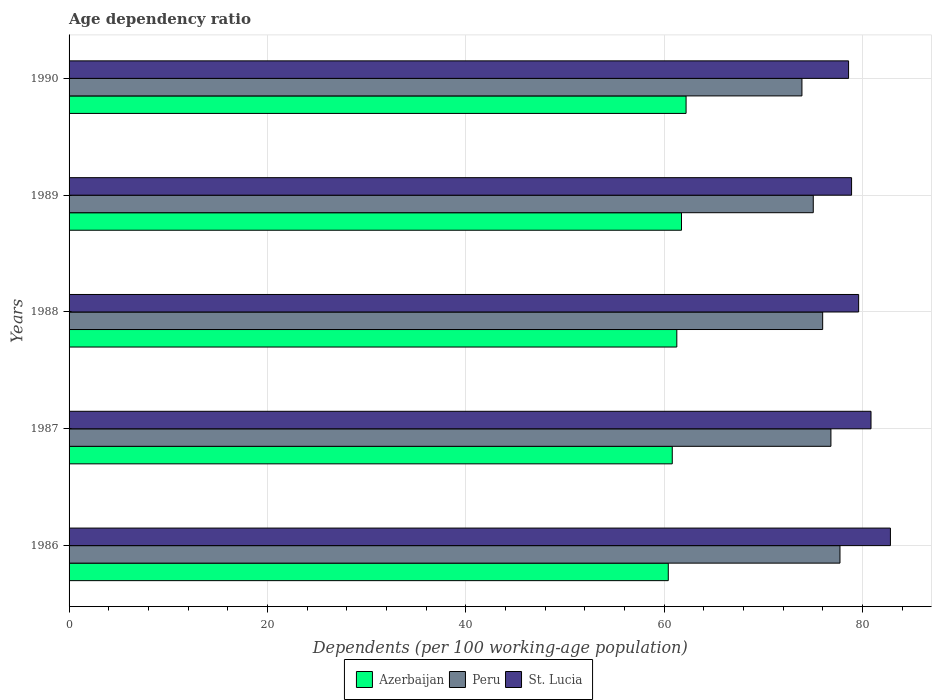How many groups of bars are there?
Offer a very short reply. 5. How many bars are there on the 1st tick from the top?
Offer a very short reply. 3. What is the label of the 3rd group of bars from the top?
Provide a succinct answer. 1988. What is the age dependency ratio in in Azerbaijan in 1989?
Offer a terse response. 61.76. Across all years, what is the maximum age dependency ratio in in Azerbaijan?
Your response must be concise. 62.22. Across all years, what is the minimum age dependency ratio in in St. Lucia?
Provide a succinct answer. 78.61. In which year was the age dependency ratio in in St. Lucia maximum?
Provide a succinct answer. 1986. In which year was the age dependency ratio in in Peru minimum?
Ensure brevity in your answer.  1990. What is the total age dependency ratio in in Azerbaijan in the graph?
Offer a terse response. 306.51. What is the difference between the age dependency ratio in in Peru in 1988 and that in 1989?
Your response must be concise. 0.95. What is the difference between the age dependency ratio in in Azerbaijan in 1987 and the age dependency ratio in in Peru in 1988?
Offer a terse response. -15.17. What is the average age dependency ratio in in Peru per year?
Keep it short and to the point. 75.9. In the year 1989, what is the difference between the age dependency ratio in in Azerbaijan and age dependency ratio in in Peru?
Your answer should be very brief. -13.29. In how many years, is the age dependency ratio in in St. Lucia greater than 16 %?
Ensure brevity in your answer.  5. What is the ratio of the age dependency ratio in in Azerbaijan in 1989 to that in 1990?
Ensure brevity in your answer.  0.99. Is the age dependency ratio in in Azerbaijan in 1986 less than that in 1989?
Your answer should be compact. Yes. What is the difference between the highest and the second highest age dependency ratio in in Peru?
Offer a very short reply. 0.91. What is the difference between the highest and the lowest age dependency ratio in in Peru?
Ensure brevity in your answer.  3.84. Is the sum of the age dependency ratio in in Peru in 1986 and 1987 greater than the maximum age dependency ratio in in Azerbaijan across all years?
Offer a terse response. Yes. What does the 1st bar from the bottom in 1990 represents?
Give a very brief answer. Azerbaijan. What is the difference between two consecutive major ticks on the X-axis?
Offer a very short reply. 20. How many legend labels are there?
Provide a short and direct response. 3. What is the title of the graph?
Provide a succinct answer. Age dependency ratio. Does "Germany" appear as one of the legend labels in the graph?
Your answer should be very brief. No. What is the label or title of the X-axis?
Keep it short and to the point. Dependents (per 100 working-age population). What is the Dependents (per 100 working-age population) of Azerbaijan in 1986?
Your answer should be compact. 60.42. What is the Dependents (per 100 working-age population) of Peru in 1986?
Give a very brief answer. 77.74. What is the Dependents (per 100 working-age population) in St. Lucia in 1986?
Keep it short and to the point. 82.83. What is the Dependents (per 100 working-age population) of Azerbaijan in 1987?
Give a very brief answer. 60.83. What is the Dependents (per 100 working-age population) in Peru in 1987?
Keep it short and to the point. 76.83. What is the Dependents (per 100 working-age population) of St. Lucia in 1987?
Your answer should be compact. 80.87. What is the Dependents (per 100 working-age population) of Azerbaijan in 1988?
Your response must be concise. 61.28. What is the Dependents (per 100 working-age population) of Peru in 1988?
Ensure brevity in your answer.  75.99. What is the Dependents (per 100 working-age population) of St. Lucia in 1988?
Your response must be concise. 79.62. What is the Dependents (per 100 working-age population) of Azerbaijan in 1989?
Offer a very short reply. 61.76. What is the Dependents (per 100 working-age population) in Peru in 1989?
Offer a terse response. 75.05. What is the Dependents (per 100 working-age population) in St. Lucia in 1989?
Your response must be concise. 78.91. What is the Dependents (per 100 working-age population) of Azerbaijan in 1990?
Provide a succinct answer. 62.22. What is the Dependents (per 100 working-age population) in Peru in 1990?
Keep it short and to the point. 73.9. What is the Dependents (per 100 working-age population) in St. Lucia in 1990?
Ensure brevity in your answer.  78.61. Across all years, what is the maximum Dependents (per 100 working-age population) in Azerbaijan?
Provide a succinct answer. 62.22. Across all years, what is the maximum Dependents (per 100 working-age population) of Peru?
Your answer should be compact. 77.74. Across all years, what is the maximum Dependents (per 100 working-age population) of St. Lucia?
Make the answer very short. 82.83. Across all years, what is the minimum Dependents (per 100 working-age population) in Azerbaijan?
Give a very brief answer. 60.42. Across all years, what is the minimum Dependents (per 100 working-age population) of Peru?
Ensure brevity in your answer.  73.9. Across all years, what is the minimum Dependents (per 100 working-age population) in St. Lucia?
Keep it short and to the point. 78.61. What is the total Dependents (per 100 working-age population) in Azerbaijan in the graph?
Offer a very short reply. 306.51. What is the total Dependents (per 100 working-age population) of Peru in the graph?
Your answer should be very brief. 379.51. What is the total Dependents (per 100 working-age population) of St. Lucia in the graph?
Keep it short and to the point. 400.83. What is the difference between the Dependents (per 100 working-age population) of Azerbaijan in 1986 and that in 1987?
Your answer should be compact. -0.4. What is the difference between the Dependents (per 100 working-age population) of Peru in 1986 and that in 1987?
Give a very brief answer. 0.91. What is the difference between the Dependents (per 100 working-age population) in St. Lucia in 1986 and that in 1987?
Give a very brief answer. 1.96. What is the difference between the Dependents (per 100 working-age population) of Azerbaijan in 1986 and that in 1988?
Your answer should be compact. -0.86. What is the difference between the Dependents (per 100 working-age population) in Peru in 1986 and that in 1988?
Give a very brief answer. 1.74. What is the difference between the Dependents (per 100 working-age population) in St. Lucia in 1986 and that in 1988?
Offer a very short reply. 3.21. What is the difference between the Dependents (per 100 working-age population) of Azerbaijan in 1986 and that in 1989?
Your response must be concise. -1.33. What is the difference between the Dependents (per 100 working-age population) of Peru in 1986 and that in 1989?
Provide a succinct answer. 2.69. What is the difference between the Dependents (per 100 working-age population) of St. Lucia in 1986 and that in 1989?
Offer a very short reply. 3.92. What is the difference between the Dependents (per 100 working-age population) in Azerbaijan in 1986 and that in 1990?
Provide a succinct answer. -1.79. What is the difference between the Dependents (per 100 working-age population) in Peru in 1986 and that in 1990?
Offer a very short reply. 3.84. What is the difference between the Dependents (per 100 working-age population) in St. Lucia in 1986 and that in 1990?
Provide a succinct answer. 4.22. What is the difference between the Dependents (per 100 working-age population) of Azerbaijan in 1987 and that in 1988?
Make the answer very short. -0.46. What is the difference between the Dependents (per 100 working-age population) of Peru in 1987 and that in 1988?
Give a very brief answer. 0.83. What is the difference between the Dependents (per 100 working-age population) of St. Lucia in 1987 and that in 1988?
Keep it short and to the point. 1.25. What is the difference between the Dependents (per 100 working-age population) in Azerbaijan in 1987 and that in 1989?
Keep it short and to the point. -0.93. What is the difference between the Dependents (per 100 working-age population) of Peru in 1987 and that in 1989?
Give a very brief answer. 1.78. What is the difference between the Dependents (per 100 working-age population) in St. Lucia in 1987 and that in 1989?
Ensure brevity in your answer.  1.96. What is the difference between the Dependents (per 100 working-age population) in Azerbaijan in 1987 and that in 1990?
Give a very brief answer. -1.39. What is the difference between the Dependents (per 100 working-age population) in Peru in 1987 and that in 1990?
Provide a succinct answer. 2.92. What is the difference between the Dependents (per 100 working-age population) in St. Lucia in 1987 and that in 1990?
Your answer should be very brief. 2.26. What is the difference between the Dependents (per 100 working-age population) of Azerbaijan in 1988 and that in 1989?
Offer a very short reply. -0.47. What is the difference between the Dependents (per 100 working-age population) of Peru in 1988 and that in 1989?
Your response must be concise. 0.95. What is the difference between the Dependents (per 100 working-age population) in St. Lucia in 1988 and that in 1989?
Ensure brevity in your answer.  0.71. What is the difference between the Dependents (per 100 working-age population) in Azerbaijan in 1988 and that in 1990?
Keep it short and to the point. -0.94. What is the difference between the Dependents (per 100 working-age population) in Peru in 1988 and that in 1990?
Offer a terse response. 2.09. What is the difference between the Dependents (per 100 working-age population) of St. Lucia in 1988 and that in 1990?
Your answer should be compact. 1.02. What is the difference between the Dependents (per 100 working-age population) of Azerbaijan in 1989 and that in 1990?
Give a very brief answer. -0.46. What is the difference between the Dependents (per 100 working-age population) of Peru in 1989 and that in 1990?
Provide a short and direct response. 1.14. What is the difference between the Dependents (per 100 working-age population) in St. Lucia in 1989 and that in 1990?
Your answer should be very brief. 0.3. What is the difference between the Dependents (per 100 working-age population) of Azerbaijan in 1986 and the Dependents (per 100 working-age population) of Peru in 1987?
Your response must be concise. -16.4. What is the difference between the Dependents (per 100 working-age population) in Azerbaijan in 1986 and the Dependents (per 100 working-age population) in St. Lucia in 1987?
Your response must be concise. -20.44. What is the difference between the Dependents (per 100 working-age population) in Peru in 1986 and the Dependents (per 100 working-age population) in St. Lucia in 1987?
Give a very brief answer. -3.13. What is the difference between the Dependents (per 100 working-age population) in Azerbaijan in 1986 and the Dependents (per 100 working-age population) in Peru in 1988?
Ensure brevity in your answer.  -15.57. What is the difference between the Dependents (per 100 working-age population) of Azerbaijan in 1986 and the Dependents (per 100 working-age population) of St. Lucia in 1988?
Offer a terse response. -19.2. What is the difference between the Dependents (per 100 working-age population) of Peru in 1986 and the Dependents (per 100 working-age population) of St. Lucia in 1988?
Give a very brief answer. -1.88. What is the difference between the Dependents (per 100 working-age population) of Azerbaijan in 1986 and the Dependents (per 100 working-age population) of Peru in 1989?
Your answer should be very brief. -14.62. What is the difference between the Dependents (per 100 working-age population) of Azerbaijan in 1986 and the Dependents (per 100 working-age population) of St. Lucia in 1989?
Keep it short and to the point. -18.48. What is the difference between the Dependents (per 100 working-age population) in Peru in 1986 and the Dependents (per 100 working-age population) in St. Lucia in 1989?
Offer a very short reply. -1.17. What is the difference between the Dependents (per 100 working-age population) of Azerbaijan in 1986 and the Dependents (per 100 working-age population) of Peru in 1990?
Your response must be concise. -13.48. What is the difference between the Dependents (per 100 working-age population) of Azerbaijan in 1986 and the Dependents (per 100 working-age population) of St. Lucia in 1990?
Give a very brief answer. -18.18. What is the difference between the Dependents (per 100 working-age population) of Peru in 1986 and the Dependents (per 100 working-age population) of St. Lucia in 1990?
Your answer should be very brief. -0.87. What is the difference between the Dependents (per 100 working-age population) of Azerbaijan in 1987 and the Dependents (per 100 working-age population) of Peru in 1988?
Provide a succinct answer. -15.17. What is the difference between the Dependents (per 100 working-age population) in Azerbaijan in 1987 and the Dependents (per 100 working-age population) in St. Lucia in 1988?
Your answer should be compact. -18.79. What is the difference between the Dependents (per 100 working-age population) of Peru in 1987 and the Dependents (per 100 working-age population) of St. Lucia in 1988?
Your response must be concise. -2.8. What is the difference between the Dependents (per 100 working-age population) of Azerbaijan in 1987 and the Dependents (per 100 working-age population) of Peru in 1989?
Provide a short and direct response. -14.22. What is the difference between the Dependents (per 100 working-age population) in Azerbaijan in 1987 and the Dependents (per 100 working-age population) in St. Lucia in 1989?
Offer a very short reply. -18.08. What is the difference between the Dependents (per 100 working-age population) of Peru in 1987 and the Dependents (per 100 working-age population) of St. Lucia in 1989?
Your response must be concise. -2.08. What is the difference between the Dependents (per 100 working-age population) of Azerbaijan in 1987 and the Dependents (per 100 working-age population) of Peru in 1990?
Your answer should be very brief. -13.08. What is the difference between the Dependents (per 100 working-age population) of Azerbaijan in 1987 and the Dependents (per 100 working-age population) of St. Lucia in 1990?
Offer a very short reply. -17.78. What is the difference between the Dependents (per 100 working-age population) of Peru in 1987 and the Dependents (per 100 working-age population) of St. Lucia in 1990?
Make the answer very short. -1.78. What is the difference between the Dependents (per 100 working-age population) of Azerbaijan in 1988 and the Dependents (per 100 working-age population) of Peru in 1989?
Provide a succinct answer. -13.76. What is the difference between the Dependents (per 100 working-age population) of Azerbaijan in 1988 and the Dependents (per 100 working-age population) of St. Lucia in 1989?
Your answer should be very brief. -17.62. What is the difference between the Dependents (per 100 working-age population) in Peru in 1988 and the Dependents (per 100 working-age population) in St. Lucia in 1989?
Your answer should be very brief. -2.91. What is the difference between the Dependents (per 100 working-age population) of Azerbaijan in 1988 and the Dependents (per 100 working-age population) of Peru in 1990?
Provide a succinct answer. -12.62. What is the difference between the Dependents (per 100 working-age population) of Azerbaijan in 1988 and the Dependents (per 100 working-age population) of St. Lucia in 1990?
Your answer should be very brief. -17.32. What is the difference between the Dependents (per 100 working-age population) in Peru in 1988 and the Dependents (per 100 working-age population) in St. Lucia in 1990?
Ensure brevity in your answer.  -2.61. What is the difference between the Dependents (per 100 working-age population) in Azerbaijan in 1989 and the Dependents (per 100 working-age population) in Peru in 1990?
Ensure brevity in your answer.  -12.15. What is the difference between the Dependents (per 100 working-age population) of Azerbaijan in 1989 and the Dependents (per 100 working-age population) of St. Lucia in 1990?
Ensure brevity in your answer.  -16.85. What is the difference between the Dependents (per 100 working-age population) of Peru in 1989 and the Dependents (per 100 working-age population) of St. Lucia in 1990?
Your response must be concise. -3.56. What is the average Dependents (per 100 working-age population) in Azerbaijan per year?
Make the answer very short. 61.3. What is the average Dependents (per 100 working-age population) in Peru per year?
Your answer should be compact. 75.9. What is the average Dependents (per 100 working-age population) in St. Lucia per year?
Provide a succinct answer. 80.17. In the year 1986, what is the difference between the Dependents (per 100 working-age population) in Azerbaijan and Dependents (per 100 working-age population) in Peru?
Keep it short and to the point. -17.31. In the year 1986, what is the difference between the Dependents (per 100 working-age population) in Azerbaijan and Dependents (per 100 working-age population) in St. Lucia?
Make the answer very short. -22.4. In the year 1986, what is the difference between the Dependents (per 100 working-age population) of Peru and Dependents (per 100 working-age population) of St. Lucia?
Provide a succinct answer. -5.09. In the year 1987, what is the difference between the Dependents (per 100 working-age population) of Azerbaijan and Dependents (per 100 working-age population) of Peru?
Your response must be concise. -16. In the year 1987, what is the difference between the Dependents (per 100 working-age population) of Azerbaijan and Dependents (per 100 working-age population) of St. Lucia?
Give a very brief answer. -20.04. In the year 1987, what is the difference between the Dependents (per 100 working-age population) of Peru and Dependents (per 100 working-age population) of St. Lucia?
Provide a short and direct response. -4.04. In the year 1988, what is the difference between the Dependents (per 100 working-age population) in Azerbaijan and Dependents (per 100 working-age population) in Peru?
Make the answer very short. -14.71. In the year 1988, what is the difference between the Dependents (per 100 working-age population) of Azerbaijan and Dependents (per 100 working-age population) of St. Lucia?
Your answer should be very brief. -18.34. In the year 1988, what is the difference between the Dependents (per 100 working-age population) in Peru and Dependents (per 100 working-age population) in St. Lucia?
Offer a terse response. -3.63. In the year 1989, what is the difference between the Dependents (per 100 working-age population) in Azerbaijan and Dependents (per 100 working-age population) in Peru?
Provide a short and direct response. -13.29. In the year 1989, what is the difference between the Dependents (per 100 working-age population) of Azerbaijan and Dependents (per 100 working-age population) of St. Lucia?
Keep it short and to the point. -17.15. In the year 1989, what is the difference between the Dependents (per 100 working-age population) in Peru and Dependents (per 100 working-age population) in St. Lucia?
Give a very brief answer. -3.86. In the year 1990, what is the difference between the Dependents (per 100 working-age population) of Azerbaijan and Dependents (per 100 working-age population) of Peru?
Make the answer very short. -11.68. In the year 1990, what is the difference between the Dependents (per 100 working-age population) in Azerbaijan and Dependents (per 100 working-age population) in St. Lucia?
Provide a succinct answer. -16.39. In the year 1990, what is the difference between the Dependents (per 100 working-age population) in Peru and Dependents (per 100 working-age population) in St. Lucia?
Provide a short and direct response. -4.7. What is the ratio of the Dependents (per 100 working-age population) of Azerbaijan in 1986 to that in 1987?
Your response must be concise. 0.99. What is the ratio of the Dependents (per 100 working-age population) in Peru in 1986 to that in 1987?
Offer a very short reply. 1.01. What is the ratio of the Dependents (per 100 working-age population) of St. Lucia in 1986 to that in 1987?
Keep it short and to the point. 1.02. What is the ratio of the Dependents (per 100 working-age population) in Azerbaijan in 1986 to that in 1988?
Make the answer very short. 0.99. What is the ratio of the Dependents (per 100 working-age population) of St. Lucia in 1986 to that in 1988?
Your answer should be compact. 1.04. What is the ratio of the Dependents (per 100 working-age population) of Azerbaijan in 1986 to that in 1989?
Keep it short and to the point. 0.98. What is the ratio of the Dependents (per 100 working-age population) in Peru in 1986 to that in 1989?
Ensure brevity in your answer.  1.04. What is the ratio of the Dependents (per 100 working-age population) of St. Lucia in 1986 to that in 1989?
Give a very brief answer. 1.05. What is the ratio of the Dependents (per 100 working-age population) of Azerbaijan in 1986 to that in 1990?
Offer a terse response. 0.97. What is the ratio of the Dependents (per 100 working-age population) of Peru in 1986 to that in 1990?
Your response must be concise. 1.05. What is the ratio of the Dependents (per 100 working-age population) of St. Lucia in 1986 to that in 1990?
Make the answer very short. 1.05. What is the ratio of the Dependents (per 100 working-age population) in Azerbaijan in 1987 to that in 1988?
Make the answer very short. 0.99. What is the ratio of the Dependents (per 100 working-age population) of Peru in 1987 to that in 1988?
Offer a terse response. 1.01. What is the ratio of the Dependents (per 100 working-age population) of St. Lucia in 1987 to that in 1988?
Provide a succinct answer. 1.02. What is the ratio of the Dependents (per 100 working-age population) in Azerbaijan in 1987 to that in 1989?
Provide a succinct answer. 0.98. What is the ratio of the Dependents (per 100 working-age population) in Peru in 1987 to that in 1989?
Provide a short and direct response. 1.02. What is the ratio of the Dependents (per 100 working-age population) of St. Lucia in 1987 to that in 1989?
Your response must be concise. 1.02. What is the ratio of the Dependents (per 100 working-age population) of Azerbaijan in 1987 to that in 1990?
Offer a very short reply. 0.98. What is the ratio of the Dependents (per 100 working-age population) in Peru in 1987 to that in 1990?
Give a very brief answer. 1.04. What is the ratio of the Dependents (per 100 working-age population) in St. Lucia in 1987 to that in 1990?
Provide a succinct answer. 1.03. What is the ratio of the Dependents (per 100 working-age population) in Peru in 1988 to that in 1989?
Give a very brief answer. 1.01. What is the ratio of the Dependents (per 100 working-age population) in Peru in 1988 to that in 1990?
Offer a very short reply. 1.03. What is the ratio of the Dependents (per 100 working-age population) of St. Lucia in 1988 to that in 1990?
Provide a succinct answer. 1.01. What is the ratio of the Dependents (per 100 working-age population) in Azerbaijan in 1989 to that in 1990?
Offer a very short reply. 0.99. What is the ratio of the Dependents (per 100 working-age population) of Peru in 1989 to that in 1990?
Your response must be concise. 1.02. What is the ratio of the Dependents (per 100 working-age population) of St. Lucia in 1989 to that in 1990?
Give a very brief answer. 1. What is the difference between the highest and the second highest Dependents (per 100 working-age population) in Azerbaijan?
Give a very brief answer. 0.46. What is the difference between the highest and the second highest Dependents (per 100 working-age population) of Peru?
Give a very brief answer. 0.91. What is the difference between the highest and the second highest Dependents (per 100 working-age population) of St. Lucia?
Provide a short and direct response. 1.96. What is the difference between the highest and the lowest Dependents (per 100 working-age population) of Azerbaijan?
Ensure brevity in your answer.  1.79. What is the difference between the highest and the lowest Dependents (per 100 working-age population) in Peru?
Provide a succinct answer. 3.84. What is the difference between the highest and the lowest Dependents (per 100 working-age population) in St. Lucia?
Your response must be concise. 4.22. 